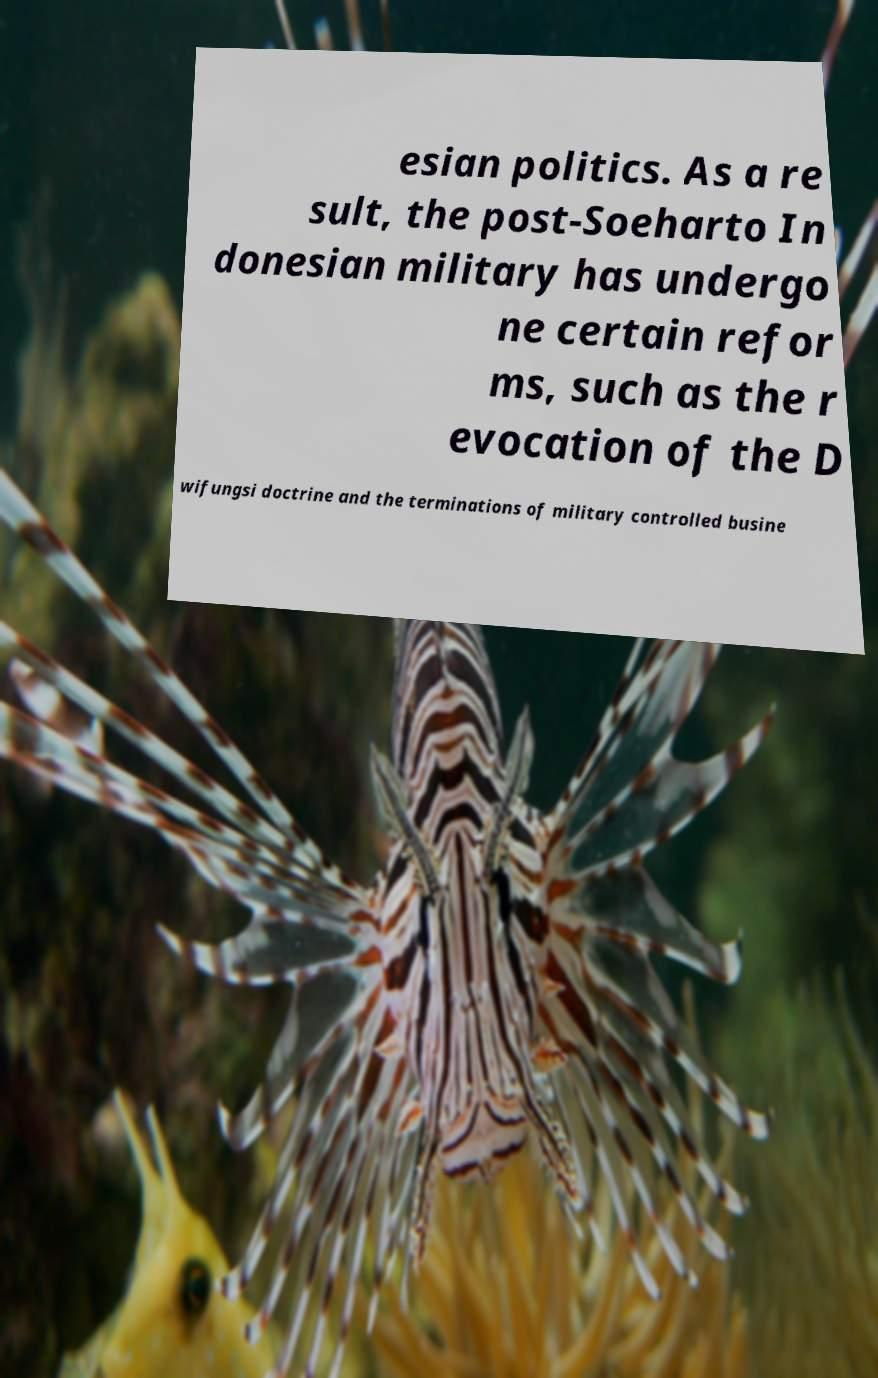There's text embedded in this image that I need extracted. Can you transcribe it verbatim? esian politics. As a re sult, the post-Soeharto In donesian military has undergo ne certain refor ms, such as the r evocation of the D wifungsi doctrine and the terminations of military controlled busine 